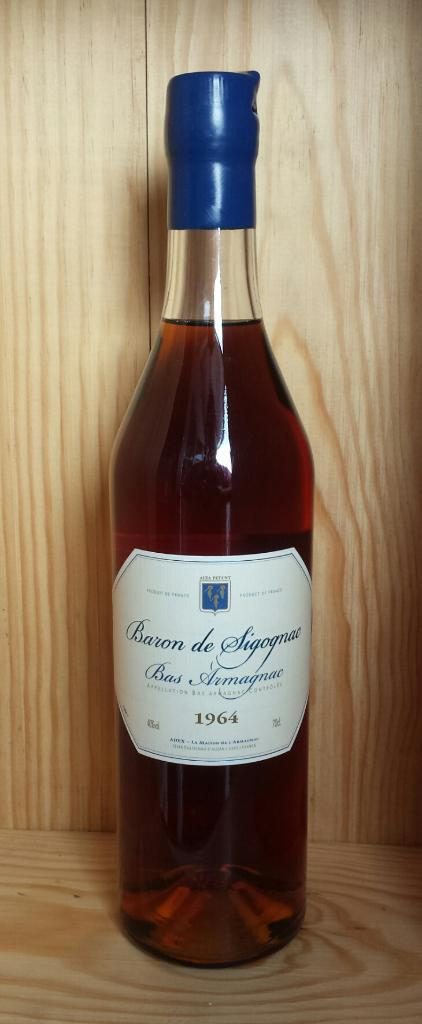Provide a one-sentence caption for the provided image. A bottle of Baron de Sigognac sits against a wooden shelf. 